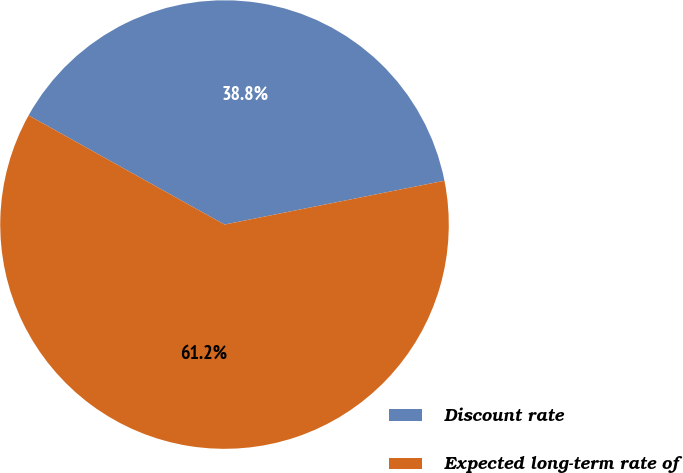<chart> <loc_0><loc_0><loc_500><loc_500><pie_chart><fcel>Discount rate<fcel>Expected long-term rate of<nl><fcel>38.78%<fcel>61.22%<nl></chart> 